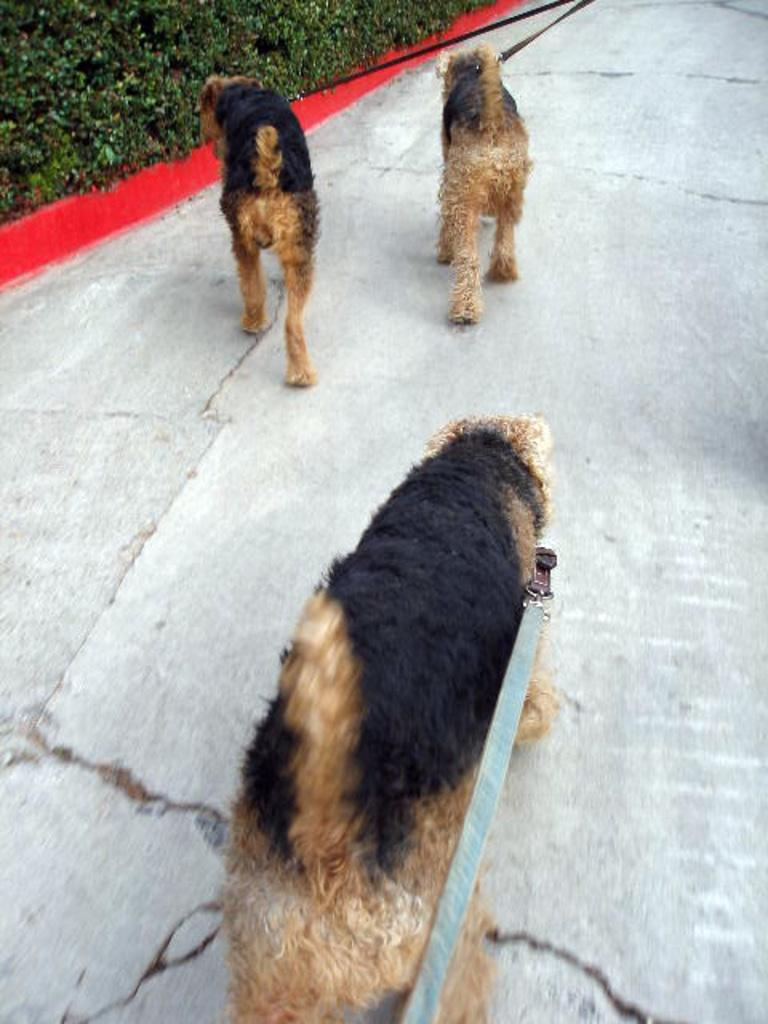How many dogs are present in the image? There are three dogs in the image. What is the position of the dogs in the image? The dogs are standing on the ground. What can be seen on the left side of the image? There are plants on the left side of the image. How are the dogs secured in the image? The dogs are tied with belts. What type of yak can be seen grazing on celery in the image? There is no yak or celery present in the image; it features three dogs standing on the ground. 